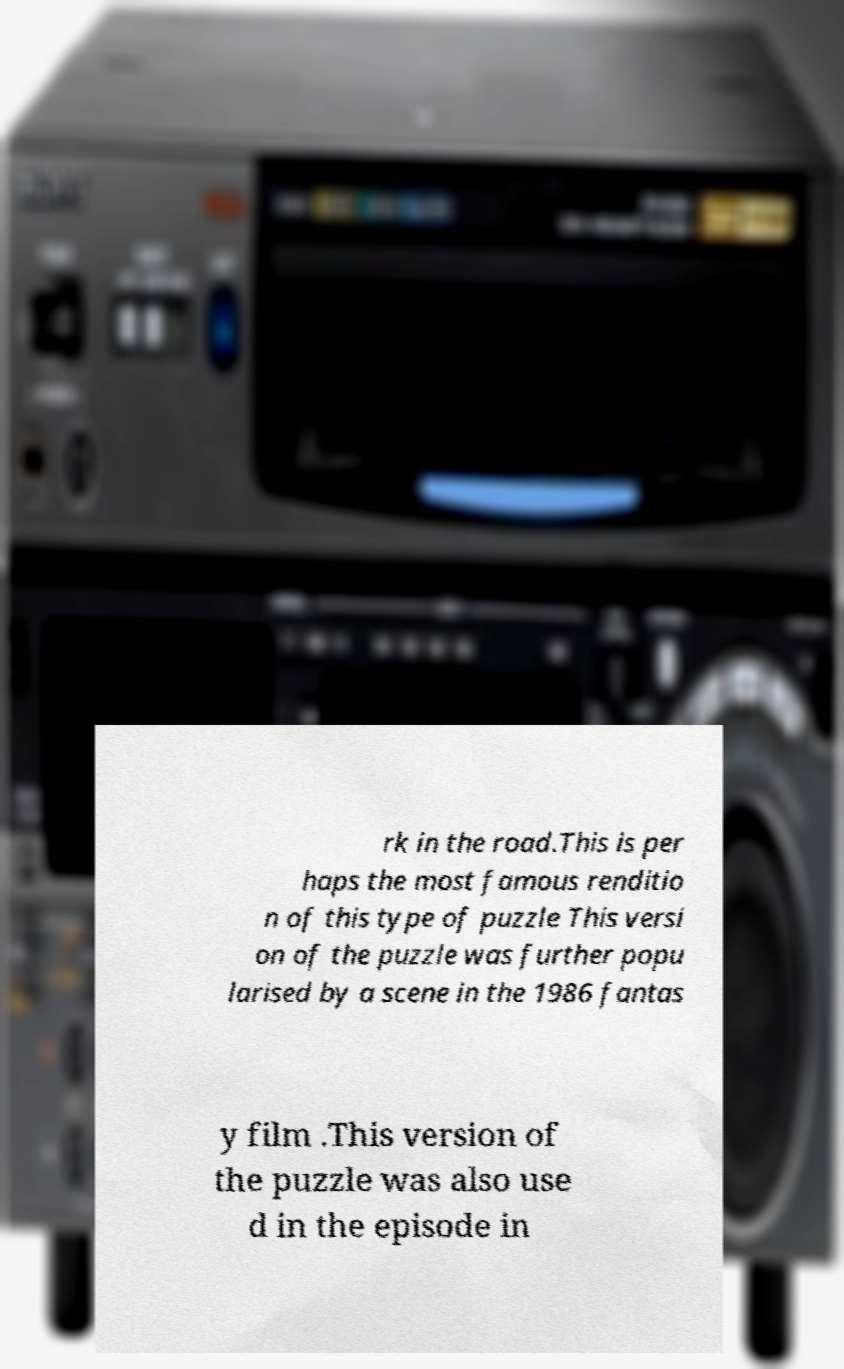Can you accurately transcribe the text from the provided image for me? rk in the road.This is per haps the most famous renditio n of this type of puzzle This versi on of the puzzle was further popu larised by a scene in the 1986 fantas y film .This version of the puzzle was also use d in the episode in 